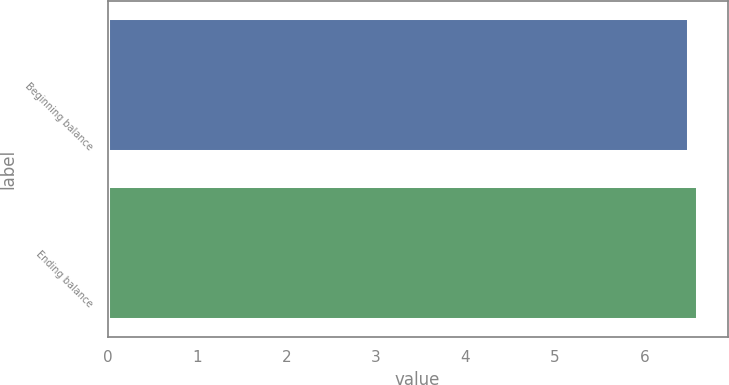Convert chart. <chart><loc_0><loc_0><loc_500><loc_500><bar_chart><fcel>Beginning balance<fcel>Ending balance<nl><fcel>6.5<fcel>6.6<nl></chart> 